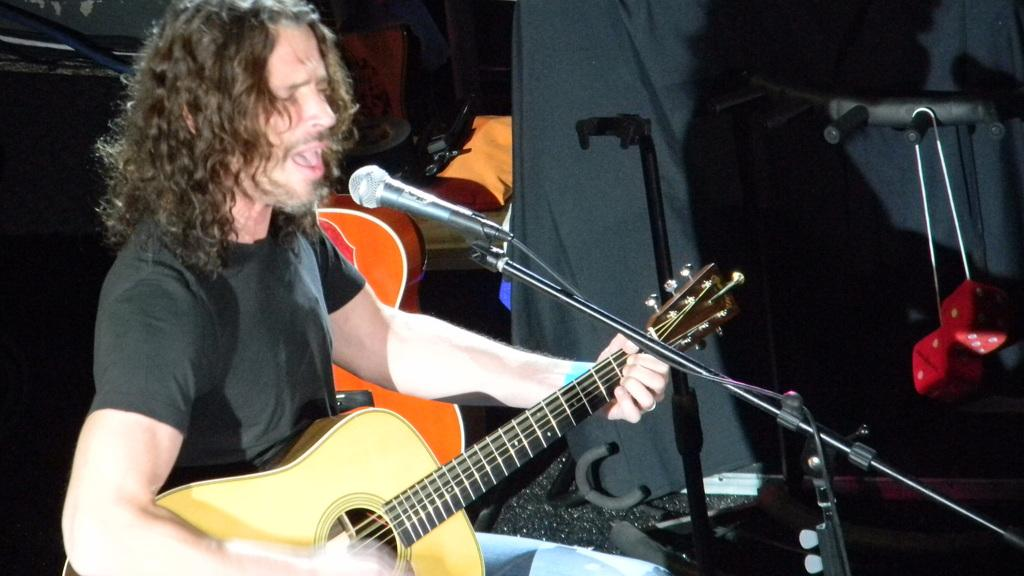What is the man in the image doing? The man is playing a guitar and singing on a mic. What instrument is the man playing in the image? The man is playing a guitar. Is the man performing a specific activity in the image? Yes, the man is playing a guitar and singing on a mic, which suggests he is performing. What type of dinosaur can be seen in the background of the image? There are no dinosaurs present in the image; it features a man playing a guitar and singing on a mic. 